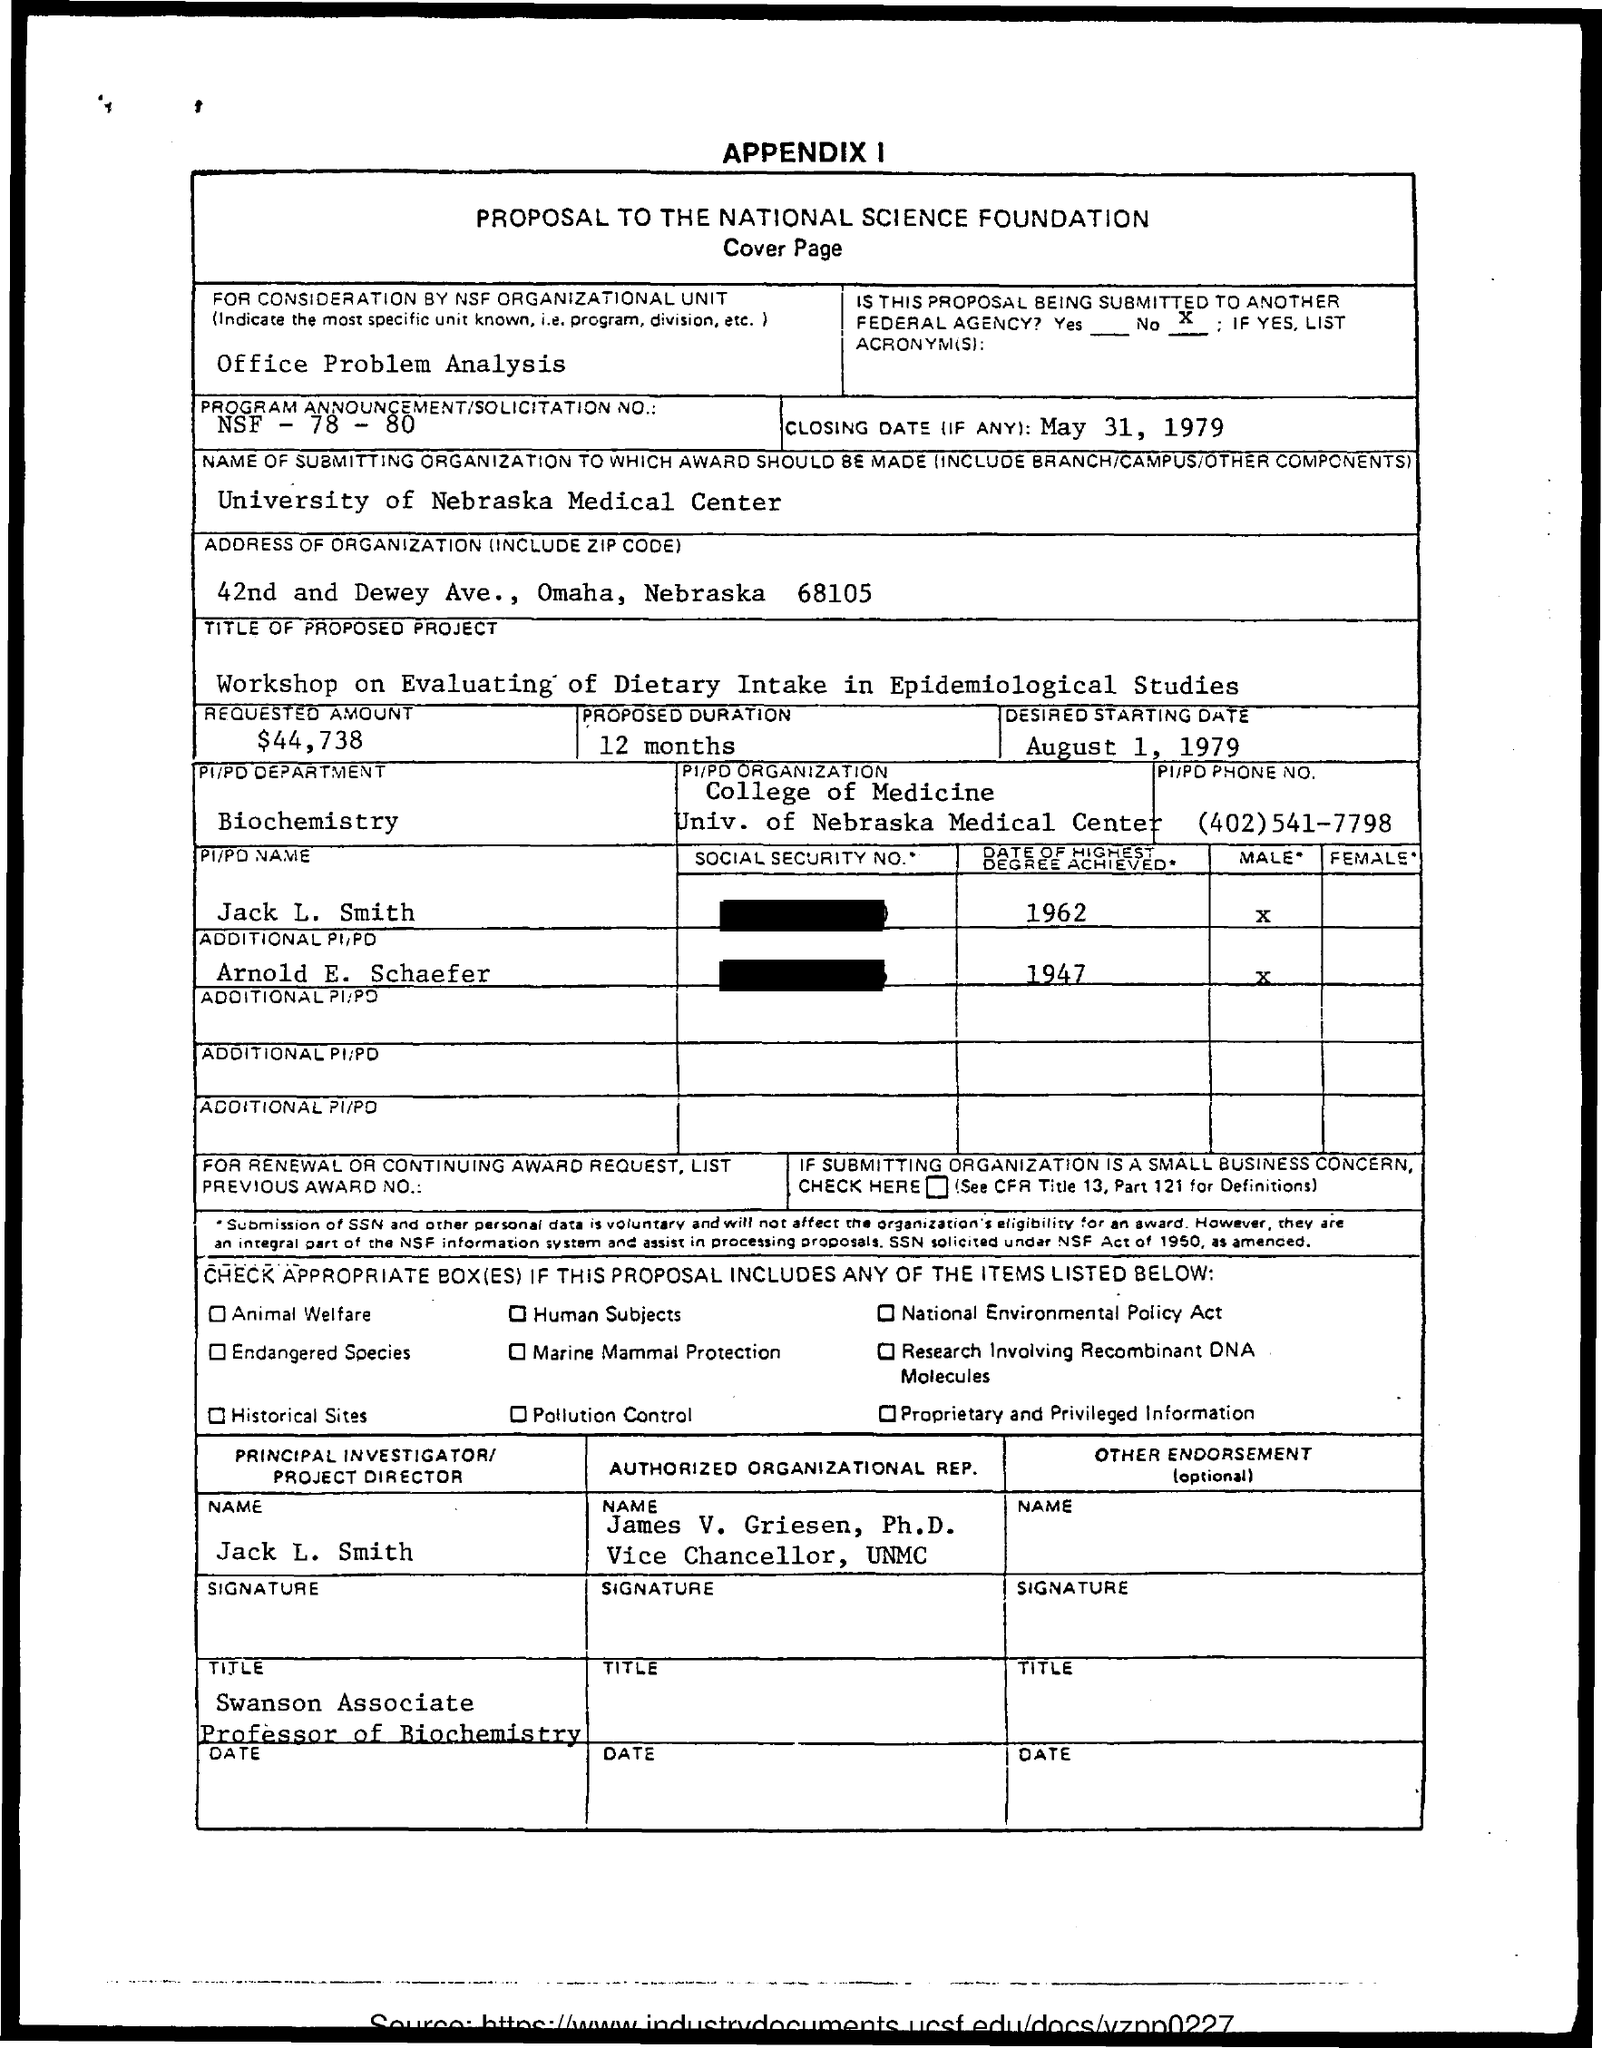Specify some key components in this picture. The submitting organization to which the award should be made is the University of Nebraska Medical Center. The closing date is May 31, 1979. The requested amount is $44,738. The phone number is (402)541-7798. The desired starting date for the document is August 1, 1979. 